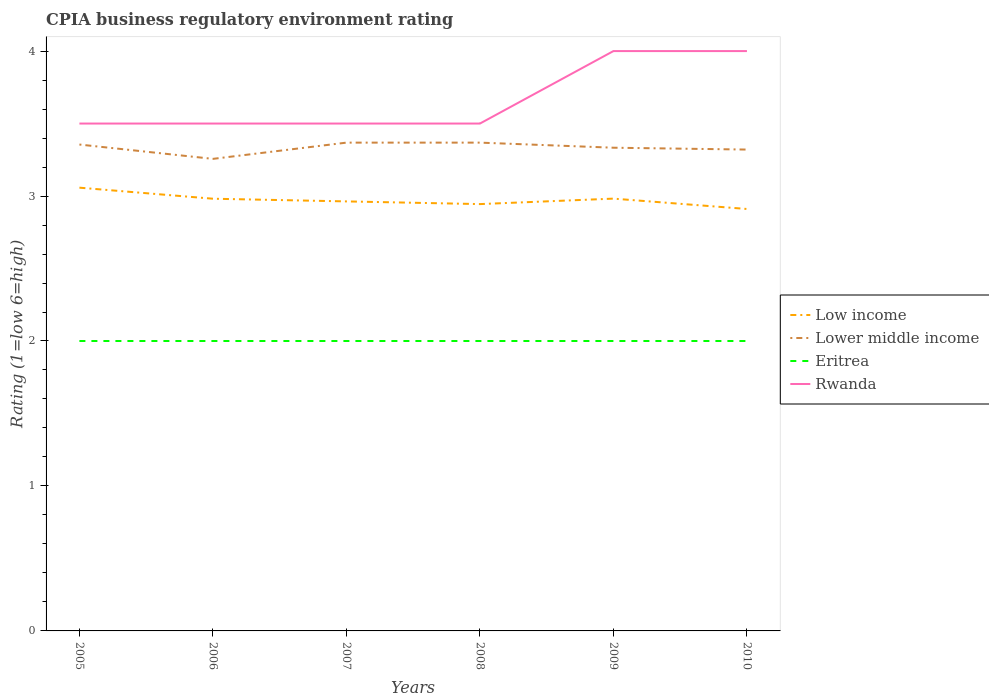How many different coloured lines are there?
Provide a short and direct response. 4. Is the number of lines equal to the number of legend labels?
Make the answer very short. Yes. Across all years, what is the maximum CPIA rating in Low income?
Keep it short and to the point. 2.91. What is the total CPIA rating in Lower middle income in the graph?
Your response must be concise. -0.01. What is the difference between the highest and the second highest CPIA rating in Rwanda?
Offer a terse response. 0.5. How many years are there in the graph?
Your answer should be very brief. 6. What is the difference between two consecutive major ticks on the Y-axis?
Your answer should be very brief. 1. Are the values on the major ticks of Y-axis written in scientific E-notation?
Your answer should be compact. No. Does the graph contain grids?
Provide a short and direct response. No. Where does the legend appear in the graph?
Make the answer very short. Center right. How many legend labels are there?
Offer a very short reply. 4. What is the title of the graph?
Your answer should be very brief. CPIA business regulatory environment rating. What is the label or title of the X-axis?
Your answer should be compact. Years. What is the label or title of the Y-axis?
Provide a succinct answer. Rating (1=low 6=high). What is the Rating (1=low 6=high) of Low income in 2005?
Offer a terse response. 3.06. What is the Rating (1=low 6=high) of Lower middle income in 2005?
Your answer should be compact. 3.36. What is the Rating (1=low 6=high) of Eritrea in 2005?
Give a very brief answer. 2. What is the Rating (1=low 6=high) in Rwanda in 2005?
Provide a succinct answer. 3.5. What is the Rating (1=low 6=high) of Low income in 2006?
Give a very brief answer. 2.98. What is the Rating (1=low 6=high) in Lower middle income in 2006?
Your response must be concise. 3.26. What is the Rating (1=low 6=high) of Eritrea in 2006?
Provide a succinct answer. 2. What is the Rating (1=low 6=high) of Rwanda in 2006?
Offer a very short reply. 3.5. What is the Rating (1=low 6=high) in Low income in 2007?
Offer a very short reply. 2.96. What is the Rating (1=low 6=high) of Lower middle income in 2007?
Keep it short and to the point. 3.37. What is the Rating (1=low 6=high) of Eritrea in 2007?
Provide a short and direct response. 2. What is the Rating (1=low 6=high) in Low income in 2008?
Your answer should be compact. 2.94. What is the Rating (1=low 6=high) in Lower middle income in 2008?
Your answer should be compact. 3.37. What is the Rating (1=low 6=high) of Low income in 2009?
Offer a terse response. 2.98. What is the Rating (1=low 6=high) in Lower middle income in 2009?
Give a very brief answer. 3.33. What is the Rating (1=low 6=high) of Rwanda in 2009?
Provide a succinct answer. 4. What is the Rating (1=low 6=high) of Low income in 2010?
Offer a very short reply. 2.91. What is the Rating (1=low 6=high) in Lower middle income in 2010?
Offer a very short reply. 3.32. Across all years, what is the maximum Rating (1=low 6=high) of Low income?
Your response must be concise. 3.06. Across all years, what is the maximum Rating (1=low 6=high) in Lower middle income?
Your answer should be very brief. 3.37. Across all years, what is the maximum Rating (1=low 6=high) in Eritrea?
Provide a succinct answer. 2. Across all years, what is the maximum Rating (1=low 6=high) of Rwanda?
Provide a short and direct response. 4. Across all years, what is the minimum Rating (1=low 6=high) in Low income?
Your response must be concise. 2.91. Across all years, what is the minimum Rating (1=low 6=high) in Lower middle income?
Provide a short and direct response. 3.26. Across all years, what is the minimum Rating (1=low 6=high) in Eritrea?
Ensure brevity in your answer.  2. What is the total Rating (1=low 6=high) in Low income in the graph?
Make the answer very short. 17.84. What is the total Rating (1=low 6=high) in Lower middle income in the graph?
Make the answer very short. 20. What is the total Rating (1=low 6=high) of Rwanda in the graph?
Give a very brief answer. 22. What is the difference between the Rating (1=low 6=high) of Low income in 2005 and that in 2006?
Offer a very short reply. 0.08. What is the difference between the Rating (1=low 6=high) of Lower middle income in 2005 and that in 2006?
Keep it short and to the point. 0.1. What is the difference between the Rating (1=low 6=high) of Eritrea in 2005 and that in 2006?
Ensure brevity in your answer.  0. What is the difference between the Rating (1=low 6=high) in Rwanda in 2005 and that in 2006?
Offer a terse response. 0. What is the difference between the Rating (1=low 6=high) in Low income in 2005 and that in 2007?
Offer a terse response. 0.09. What is the difference between the Rating (1=low 6=high) of Lower middle income in 2005 and that in 2007?
Keep it short and to the point. -0.01. What is the difference between the Rating (1=low 6=high) in Eritrea in 2005 and that in 2007?
Your answer should be compact. 0. What is the difference between the Rating (1=low 6=high) in Low income in 2005 and that in 2008?
Your response must be concise. 0.11. What is the difference between the Rating (1=low 6=high) of Lower middle income in 2005 and that in 2008?
Make the answer very short. -0.01. What is the difference between the Rating (1=low 6=high) in Rwanda in 2005 and that in 2008?
Ensure brevity in your answer.  0. What is the difference between the Rating (1=low 6=high) of Low income in 2005 and that in 2009?
Provide a succinct answer. 0.08. What is the difference between the Rating (1=low 6=high) of Lower middle income in 2005 and that in 2009?
Offer a terse response. 0.02. What is the difference between the Rating (1=low 6=high) in Eritrea in 2005 and that in 2009?
Offer a very short reply. 0. What is the difference between the Rating (1=low 6=high) of Rwanda in 2005 and that in 2009?
Offer a very short reply. -0.5. What is the difference between the Rating (1=low 6=high) in Low income in 2005 and that in 2010?
Give a very brief answer. 0.15. What is the difference between the Rating (1=low 6=high) of Lower middle income in 2005 and that in 2010?
Keep it short and to the point. 0.03. What is the difference between the Rating (1=low 6=high) in Eritrea in 2005 and that in 2010?
Your answer should be compact. 0. What is the difference between the Rating (1=low 6=high) of Rwanda in 2005 and that in 2010?
Offer a terse response. -0.5. What is the difference between the Rating (1=low 6=high) in Low income in 2006 and that in 2007?
Provide a short and direct response. 0.02. What is the difference between the Rating (1=low 6=high) in Lower middle income in 2006 and that in 2007?
Ensure brevity in your answer.  -0.11. What is the difference between the Rating (1=low 6=high) of Eritrea in 2006 and that in 2007?
Provide a short and direct response. 0. What is the difference between the Rating (1=low 6=high) in Rwanda in 2006 and that in 2007?
Provide a short and direct response. 0. What is the difference between the Rating (1=low 6=high) of Low income in 2006 and that in 2008?
Ensure brevity in your answer.  0.04. What is the difference between the Rating (1=low 6=high) in Lower middle income in 2006 and that in 2008?
Your answer should be compact. -0.11. What is the difference between the Rating (1=low 6=high) in Eritrea in 2006 and that in 2008?
Make the answer very short. 0. What is the difference between the Rating (1=low 6=high) in Low income in 2006 and that in 2009?
Offer a very short reply. -0. What is the difference between the Rating (1=low 6=high) in Lower middle income in 2006 and that in 2009?
Keep it short and to the point. -0.08. What is the difference between the Rating (1=low 6=high) of Low income in 2006 and that in 2010?
Ensure brevity in your answer.  0.07. What is the difference between the Rating (1=low 6=high) of Lower middle income in 2006 and that in 2010?
Keep it short and to the point. -0.06. What is the difference between the Rating (1=low 6=high) of Eritrea in 2006 and that in 2010?
Offer a terse response. 0. What is the difference between the Rating (1=low 6=high) in Low income in 2007 and that in 2008?
Offer a very short reply. 0.02. What is the difference between the Rating (1=low 6=high) of Lower middle income in 2007 and that in 2008?
Keep it short and to the point. 0. What is the difference between the Rating (1=low 6=high) of Rwanda in 2007 and that in 2008?
Offer a very short reply. 0. What is the difference between the Rating (1=low 6=high) in Low income in 2007 and that in 2009?
Offer a terse response. -0.02. What is the difference between the Rating (1=low 6=high) of Lower middle income in 2007 and that in 2009?
Your answer should be very brief. 0.04. What is the difference between the Rating (1=low 6=high) in Low income in 2007 and that in 2010?
Provide a short and direct response. 0.05. What is the difference between the Rating (1=low 6=high) in Lower middle income in 2007 and that in 2010?
Your response must be concise. 0.05. What is the difference between the Rating (1=low 6=high) of Rwanda in 2007 and that in 2010?
Your answer should be very brief. -0.5. What is the difference between the Rating (1=low 6=high) in Low income in 2008 and that in 2009?
Ensure brevity in your answer.  -0.04. What is the difference between the Rating (1=low 6=high) of Lower middle income in 2008 and that in 2009?
Ensure brevity in your answer.  0.04. What is the difference between the Rating (1=low 6=high) of Low income in 2008 and that in 2010?
Your response must be concise. 0.03. What is the difference between the Rating (1=low 6=high) of Lower middle income in 2008 and that in 2010?
Offer a very short reply. 0.05. What is the difference between the Rating (1=low 6=high) in Eritrea in 2008 and that in 2010?
Your answer should be very brief. 0. What is the difference between the Rating (1=low 6=high) of Low income in 2009 and that in 2010?
Provide a succinct answer. 0.07. What is the difference between the Rating (1=low 6=high) of Lower middle income in 2009 and that in 2010?
Provide a succinct answer. 0.01. What is the difference between the Rating (1=low 6=high) in Eritrea in 2009 and that in 2010?
Provide a succinct answer. 0. What is the difference between the Rating (1=low 6=high) of Low income in 2005 and the Rating (1=low 6=high) of Lower middle income in 2006?
Offer a very short reply. -0.2. What is the difference between the Rating (1=low 6=high) in Low income in 2005 and the Rating (1=low 6=high) in Eritrea in 2006?
Give a very brief answer. 1.06. What is the difference between the Rating (1=low 6=high) of Low income in 2005 and the Rating (1=low 6=high) of Rwanda in 2006?
Offer a very short reply. -0.44. What is the difference between the Rating (1=low 6=high) of Lower middle income in 2005 and the Rating (1=low 6=high) of Eritrea in 2006?
Offer a terse response. 1.36. What is the difference between the Rating (1=low 6=high) in Lower middle income in 2005 and the Rating (1=low 6=high) in Rwanda in 2006?
Your answer should be compact. -0.14. What is the difference between the Rating (1=low 6=high) of Eritrea in 2005 and the Rating (1=low 6=high) of Rwanda in 2006?
Your answer should be very brief. -1.5. What is the difference between the Rating (1=low 6=high) in Low income in 2005 and the Rating (1=low 6=high) in Lower middle income in 2007?
Offer a terse response. -0.31. What is the difference between the Rating (1=low 6=high) in Low income in 2005 and the Rating (1=low 6=high) in Eritrea in 2007?
Your response must be concise. 1.06. What is the difference between the Rating (1=low 6=high) in Low income in 2005 and the Rating (1=low 6=high) in Rwanda in 2007?
Offer a very short reply. -0.44. What is the difference between the Rating (1=low 6=high) of Lower middle income in 2005 and the Rating (1=low 6=high) of Eritrea in 2007?
Your answer should be very brief. 1.36. What is the difference between the Rating (1=low 6=high) in Lower middle income in 2005 and the Rating (1=low 6=high) in Rwanda in 2007?
Your response must be concise. -0.14. What is the difference between the Rating (1=low 6=high) in Eritrea in 2005 and the Rating (1=low 6=high) in Rwanda in 2007?
Your response must be concise. -1.5. What is the difference between the Rating (1=low 6=high) of Low income in 2005 and the Rating (1=low 6=high) of Lower middle income in 2008?
Your answer should be very brief. -0.31. What is the difference between the Rating (1=low 6=high) of Low income in 2005 and the Rating (1=low 6=high) of Eritrea in 2008?
Provide a short and direct response. 1.06. What is the difference between the Rating (1=low 6=high) of Low income in 2005 and the Rating (1=low 6=high) of Rwanda in 2008?
Offer a terse response. -0.44. What is the difference between the Rating (1=low 6=high) in Lower middle income in 2005 and the Rating (1=low 6=high) in Eritrea in 2008?
Offer a very short reply. 1.36. What is the difference between the Rating (1=low 6=high) of Lower middle income in 2005 and the Rating (1=low 6=high) of Rwanda in 2008?
Provide a short and direct response. -0.14. What is the difference between the Rating (1=low 6=high) of Eritrea in 2005 and the Rating (1=low 6=high) of Rwanda in 2008?
Offer a terse response. -1.5. What is the difference between the Rating (1=low 6=high) of Low income in 2005 and the Rating (1=low 6=high) of Lower middle income in 2009?
Provide a short and direct response. -0.28. What is the difference between the Rating (1=low 6=high) in Low income in 2005 and the Rating (1=low 6=high) in Eritrea in 2009?
Offer a terse response. 1.06. What is the difference between the Rating (1=low 6=high) of Low income in 2005 and the Rating (1=low 6=high) of Rwanda in 2009?
Provide a short and direct response. -0.94. What is the difference between the Rating (1=low 6=high) in Lower middle income in 2005 and the Rating (1=low 6=high) in Eritrea in 2009?
Your answer should be compact. 1.36. What is the difference between the Rating (1=low 6=high) of Lower middle income in 2005 and the Rating (1=low 6=high) of Rwanda in 2009?
Your answer should be very brief. -0.64. What is the difference between the Rating (1=low 6=high) in Eritrea in 2005 and the Rating (1=low 6=high) in Rwanda in 2009?
Make the answer very short. -2. What is the difference between the Rating (1=low 6=high) in Low income in 2005 and the Rating (1=low 6=high) in Lower middle income in 2010?
Make the answer very short. -0.26. What is the difference between the Rating (1=low 6=high) in Low income in 2005 and the Rating (1=low 6=high) in Eritrea in 2010?
Give a very brief answer. 1.06. What is the difference between the Rating (1=low 6=high) in Low income in 2005 and the Rating (1=low 6=high) in Rwanda in 2010?
Your response must be concise. -0.94. What is the difference between the Rating (1=low 6=high) of Lower middle income in 2005 and the Rating (1=low 6=high) of Eritrea in 2010?
Offer a very short reply. 1.36. What is the difference between the Rating (1=low 6=high) of Lower middle income in 2005 and the Rating (1=low 6=high) of Rwanda in 2010?
Give a very brief answer. -0.64. What is the difference between the Rating (1=low 6=high) in Low income in 2006 and the Rating (1=low 6=high) in Lower middle income in 2007?
Keep it short and to the point. -0.39. What is the difference between the Rating (1=low 6=high) in Low income in 2006 and the Rating (1=low 6=high) in Eritrea in 2007?
Offer a very short reply. 0.98. What is the difference between the Rating (1=low 6=high) of Low income in 2006 and the Rating (1=low 6=high) of Rwanda in 2007?
Keep it short and to the point. -0.52. What is the difference between the Rating (1=low 6=high) of Lower middle income in 2006 and the Rating (1=low 6=high) of Eritrea in 2007?
Keep it short and to the point. 1.26. What is the difference between the Rating (1=low 6=high) of Lower middle income in 2006 and the Rating (1=low 6=high) of Rwanda in 2007?
Provide a succinct answer. -0.24. What is the difference between the Rating (1=low 6=high) of Eritrea in 2006 and the Rating (1=low 6=high) of Rwanda in 2007?
Your answer should be very brief. -1.5. What is the difference between the Rating (1=low 6=high) of Low income in 2006 and the Rating (1=low 6=high) of Lower middle income in 2008?
Your answer should be very brief. -0.39. What is the difference between the Rating (1=low 6=high) of Low income in 2006 and the Rating (1=low 6=high) of Eritrea in 2008?
Provide a short and direct response. 0.98. What is the difference between the Rating (1=low 6=high) of Low income in 2006 and the Rating (1=low 6=high) of Rwanda in 2008?
Offer a terse response. -0.52. What is the difference between the Rating (1=low 6=high) of Lower middle income in 2006 and the Rating (1=low 6=high) of Eritrea in 2008?
Keep it short and to the point. 1.26. What is the difference between the Rating (1=low 6=high) in Lower middle income in 2006 and the Rating (1=low 6=high) in Rwanda in 2008?
Your answer should be compact. -0.24. What is the difference between the Rating (1=low 6=high) of Eritrea in 2006 and the Rating (1=low 6=high) of Rwanda in 2008?
Offer a terse response. -1.5. What is the difference between the Rating (1=low 6=high) of Low income in 2006 and the Rating (1=low 6=high) of Lower middle income in 2009?
Ensure brevity in your answer.  -0.35. What is the difference between the Rating (1=low 6=high) of Low income in 2006 and the Rating (1=low 6=high) of Eritrea in 2009?
Provide a succinct answer. 0.98. What is the difference between the Rating (1=low 6=high) in Low income in 2006 and the Rating (1=low 6=high) in Rwanda in 2009?
Offer a very short reply. -1.02. What is the difference between the Rating (1=low 6=high) in Lower middle income in 2006 and the Rating (1=low 6=high) in Eritrea in 2009?
Provide a short and direct response. 1.26. What is the difference between the Rating (1=low 6=high) in Lower middle income in 2006 and the Rating (1=low 6=high) in Rwanda in 2009?
Offer a very short reply. -0.74. What is the difference between the Rating (1=low 6=high) in Eritrea in 2006 and the Rating (1=low 6=high) in Rwanda in 2009?
Keep it short and to the point. -2. What is the difference between the Rating (1=low 6=high) in Low income in 2006 and the Rating (1=low 6=high) in Lower middle income in 2010?
Give a very brief answer. -0.34. What is the difference between the Rating (1=low 6=high) in Low income in 2006 and the Rating (1=low 6=high) in Eritrea in 2010?
Provide a short and direct response. 0.98. What is the difference between the Rating (1=low 6=high) of Low income in 2006 and the Rating (1=low 6=high) of Rwanda in 2010?
Provide a short and direct response. -1.02. What is the difference between the Rating (1=low 6=high) in Lower middle income in 2006 and the Rating (1=low 6=high) in Eritrea in 2010?
Your response must be concise. 1.26. What is the difference between the Rating (1=low 6=high) in Lower middle income in 2006 and the Rating (1=low 6=high) in Rwanda in 2010?
Your response must be concise. -0.74. What is the difference between the Rating (1=low 6=high) in Eritrea in 2006 and the Rating (1=low 6=high) in Rwanda in 2010?
Make the answer very short. -2. What is the difference between the Rating (1=low 6=high) in Low income in 2007 and the Rating (1=low 6=high) in Lower middle income in 2008?
Provide a succinct answer. -0.41. What is the difference between the Rating (1=low 6=high) in Low income in 2007 and the Rating (1=low 6=high) in Rwanda in 2008?
Make the answer very short. -0.54. What is the difference between the Rating (1=low 6=high) in Lower middle income in 2007 and the Rating (1=low 6=high) in Eritrea in 2008?
Offer a very short reply. 1.37. What is the difference between the Rating (1=low 6=high) of Lower middle income in 2007 and the Rating (1=low 6=high) of Rwanda in 2008?
Your response must be concise. -0.13. What is the difference between the Rating (1=low 6=high) in Low income in 2007 and the Rating (1=low 6=high) in Lower middle income in 2009?
Keep it short and to the point. -0.37. What is the difference between the Rating (1=low 6=high) in Low income in 2007 and the Rating (1=low 6=high) in Rwanda in 2009?
Offer a terse response. -1.04. What is the difference between the Rating (1=low 6=high) in Lower middle income in 2007 and the Rating (1=low 6=high) in Eritrea in 2009?
Give a very brief answer. 1.37. What is the difference between the Rating (1=low 6=high) in Lower middle income in 2007 and the Rating (1=low 6=high) in Rwanda in 2009?
Give a very brief answer. -0.63. What is the difference between the Rating (1=low 6=high) in Low income in 2007 and the Rating (1=low 6=high) in Lower middle income in 2010?
Your answer should be compact. -0.36. What is the difference between the Rating (1=low 6=high) in Low income in 2007 and the Rating (1=low 6=high) in Eritrea in 2010?
Provide a succinct answer. 0.96. What is the difference between the Rating (1=low 6=high) in Low income in 2007 and the Rating (1=low 6=high) in Rwanda in 2010?
Your answer should be compact. -1.04. What is the difference between the Rating (1=low 6=high) of Lower middle income in 2007 and the Rating (1=low 6=high) of Eritrea in 2010?
Make the answer very short. 1.37. What is the difference between the Rating (1=low 6=high) in Lower middle income in 2007 and the Rating (1=low 6=high) in Rwanda in 2010?
Provide a succinct answer. -0.63. What is the difference between the Rating (1=low 6=high) in Eritrea in 2007 and the Rating (1=low 6=high) in Rwanda in 2010?
Your answer should be very brief. -2. What is the difference between the Rating (1=low 6=high) in Low income in 2008 and the Rating (1=low 6=high) in Lower middle income in 2009?
Your answer should be very brief. -0.39. What is the difference between the Rating (1=low 6=high) in Low income in 2008 and the Rating (1=low 6=high) in Rwanda in 2009?
Your response must be concise. -1.06. What is the difference between the Rating (1=low 6=high) of Lower middle income in 2008 and the Rating (1=low 6=high) of Eritrea in 2009?
Offer a terse response. 1.37. What is the difference between the Rating (1=low 6=high) of Lower middle income in 2008 and the Rating (1=low 6=high) of Rwanda in 2009?
Provide a succinct answer. -0.63. What is the difference between the Rating (1=low 6=high) of Eritrea in 2008 and the Rating (1=low 6=high) of Rwanda in 2009?
Offer a very short reply. -2. What is the difference between the Rating (1=low 6=high) in Low income in 2008 and the Rating (1=low 6=high) in Lower middle income in 2010?
Give a very brief answer. -0.38. What is the difference between the Rating (1=low 6=high) in Low income in 2008 and the Rating (1=low 6=high) in Rwanda in 2010?
Ensure brevity in your answer.  -1.06. What is the difference between the Rating (1=low 6=high) in Lower middle income in 2008 and the Rating (1=low 6=high) in Eritrea in 2010?
Your answer should be compact. 1.37. What is the difference between the Rating (1=low 6=high) of Lower middle income in 2008 and the Rating (1=low 6=high) of Rwanda in 2010?
Provide a short and direct response. -0.63. What is the difference between the Rating (1=low 6=high) in Eritrea in 2008 and the Rating (1=low 6=high) in Rwanda in 2010?
Offer a terse response. -2. What is the difference between the Rating (1=low 6=high) in Low income in 2009 and the Rating (1=low 6=high) in Lower middle income in 2010?
Your answer should be very brief. -0.34. What is the difference between the Rating (1=low 6=high) in Low income in 2009 and the Rating (1=low 6=high) in Eritrea in 2010?
Provide a short and direct response. 0.98. What is the difference between the Rating (1=low 6=high) in Low income in 2009 and the Rating (1=low 6=high) in Rwanda in 2010?
Give a very brief answer. -1.02. What is the average Rating (1=low 6=high) of Low income per year?
Your answer should be very brief. 2.97. What is the average Rating (1=low 6=high) in Lower middle income per year?
Make the answer very short. 3.33. What is the average Rating (1=low 6=high) in Eritrea per year?
Offer a terse response. 2. What is the average Rating (1=low 6=high) of Rwanda per year?
Provide a succinct answer. 3.67. In the year 2005, what is the difference between the Rating (1=low 6=high) of Low income and Rating (1=low 6=high) of Lower middle income?
Your response must be concise. -0.3. In the year 2005, what is the difference between the Rating (1=low 6=high) in Low income and Rating (1=low 6=high) in Eritrea?
Offer a very short reply. 1.06. In the year 2005, what is the difference between the Rating (1=low 6=high) in Low income and Rating (1=low 6=high) in Rwanda?
Provide a succinct answer. -0.44. In the year 2005, what is the difference between the Rating (1=low 6=high) in Lower middle income and Rating (1=low 6=high) in Eritrea?
Provide a succinct answer. 1.36. In the year 2005, what is the difference between the Rating (1=low 6=high) in Lower middle income and Rating (1=low 6=high) in Rwanda?
Your answer should be compact. -0.14. In the year 2005, what is the difference between the Rating (1=low 6=high) in Eritrea and Rating (1=low 6=high) in Rwanda?
Your response must be concise. -1.5. In the year 2006, what is the difference between the Rating (1=low 6=high) of Low income and Rating (1=low 6=high) of Lower middle income?
Offer a very short reply. -0.27. In the year 2006, what is the difference between the Rating (1=low 6=high) of Low income and Rating (1=low 6=high) of Eritrea?
Make the answer very short. 0.98. In the year 2006, what is the difference between the Rating (1=low 6=high) in Low income and Rating (1=low 6=high) in Rwanda?
Give a very brief answer. -0.52. In the year 2006, what is the difference between the Rating (1=low 6=high) of Lower middle income and Rating (1=low 6=high) of Eritrea?
Ensure brevity in your answer.  1.26. In the year 2006, what is the difference between the Rating (1=low 6=high) of Lower middle income and Rating (1=low 6=high) of Rwanda?
Offer a terse response. -0.24. In the year 2006, what is the difference between the Rating (1=low 6=high) of Eritrea and Rating (1=low 6=high) of Rwanda?
Your answer should be compact. -1.5. In the year 2007, what is the difference between the Rating (1=low 6=high) of Low income and Rating (1=low 6=high) of Lower middle income?
Offer a very short reply. -0.41. In the year 2007, what is the difference between the Rating (1=low 6=high) of Low income and Rating (1=low 6=high) of Rwanda?
Make the answer very short. -0.54. In the year 2007, what is the difference between the Rating (1=low 6=high) in Lower middle income and Rating (1=low 6=high) in Eritrea?
Offer a very short reply. 1.37. In the year 2007, what is the difference between the Rating (1=low 6=high) of Lower middle income and Rating (1=low 6=high) of Rwanda?
Offer a very short reply. -0.13. In the year 2007, what is the difference between the Rating (1=low 6=high) in Eritrea and Rating (1=low 6=high) in Rwanda?
Offer a very short reply. -1.5. In the year 2008, what is the difference between the Rating (1=low 6=high) of Low income and Rating (1=low 6=high) of Lower middle income?
Ensure brevity in your answer.  -0.42. In the year 2008, what is the difference between the Rating (1=low 6=high) of Low income and Rating (1=low 6=high) of Rwanda?
Your answer should be compact. -0.56. In the year 2008, what is the difference between the Rating (1=low 6=high) of Lower middle income and Rating (1=low 6=high) of Eritrea?
Your response must be concise. 1.37. In the year 2008, what is the difference between the Rating (1=low 6=high) in Lower middle income and Rating (1=low 6=high) in Rwanda?
Make the answer very short. -0.13. In the year 2009, what is the difference between the Rating (1=low 6=high) in Low income and Rating (1=low 6=high) in Lower middle income?
Provide a succinct answer. -0.35. In the year 2009, what is the difference between the Rating (1=low 6=high) in Low income and Rating (1=low 6=high) in Eritrea?
Give a very brief answer. 0.98. In the year 2009, what is the difference between the Rating (1=low 6=high) in Low income and Rating (1=low 6=high) in Rwanda?
Your response must be concise. -1.02. In the year 2009, what is the difference between the Rating (1=low 6=high) in Lower middle income and Rating (1=low 6=high) in Rwanda?
Offer a very short reply. -0.67. In the year 2010, what is the difference between the Rating (1=low 6=high) of Low income and Rating (1=low 6=high) of Lower middle income?
Make the answer very short. -0.41. In the year 2010, what is the difference between the Rating (1=low 6=high) in Low income and Rating (1=low 6=high) in Eritrea?
Make the answer very short. 0.91. In the year 2010, what is the difference between the Rating (1=low 6=high) of Low income and Rating (1=low 6=high) of Rwanda?
Give a very brief answer. -1.09. In the year 2010, what is the difference between the Rating (1=low 6=high) in Lower middle income and Rating (1=low 6=high) in Eritrea?
Your answer should be compact. 1.32. In the year 2010, what is the difference between the Rating (1=low 6=high) of Lower middle income and Rating (1=low 6=high) of Rwanda?
Offer a terse response. -0.68. In the year 2010, what is the difference between the Rating (1=low 6=high) of Eritrea and Rating (1=low 6=high) of Rwanda?
Ensure brevity in your answer.  -2. What is the ratio of the Rating (1=low 6=high) in Low income in 2005 to that in 2006?
Offer a terse response. 1.03. What is the ratio of the Rating (1=low 6=high) in Lower middle income in 2005 to that in 2006?
Ensure brevity in your answer.  1.03. What is the ratio of the Rating (1=low 6=high) of Rwanda in 2005 to that in 2006?
Provide a succinct answer. 1. What is the ratio of the Rating (1=low 6=high) of Low income in 2005 to that in 2007?
Provide a short and direct response. 1.03. What is the ratio of the Rating (1=low 6=high) in Rwanda in 2005 to that in 2007?
Give a very brief answer. 1. What is the ratio of the Rating (1=low 6=high) in Eritrea in 2005 to that in 2008?
Your answer should be very brief. 1. What is the ratio of the Rating (1=low 6=high) of Low income in 2005 to that in 2009?
Your answer should be compact. 1.03. What is the ratio of the Rating (1=low 6=high) of Lower middle income in 2005 to that in 2009?
Provide a short and direct response. 1.01. What is the ratio of the Rating (1=low 6=high) in Eritrea in 2005 to that in 2009?
Offer a terse response. 1. What is the ratio of the Rating (1=low 6=high) of Low income in 2005 to that in 2010?
Ensure brevity in your answer.  1.05. What is the ratio of the Rating (1=low 6=high) in Lower middle income in 2005 to that in 2010?
Offer a terse response. 1.01. What is the ratio of the Rating (1=low 6=high) of Lower middle income in 2006 to that in 2007?
Provide a short and direct response. 0.97. What is the ratio of the Rating (1=low 6=high) of Eritrea in 2006 to that in 2007?
Keep it short and to the point. 1. What is the ratio of the Rating (1=low 6=high) of Rwanda in 2006 to that in 2007?
Your answer should be very brief. 1. What is the ratio of the Rating (1=low 6=high) in Low income in 2006 to that in 2008?
Keep it short and to the point. 1.01. What is the ratio of the Rating (1=low 6=high) of Lower middle income in 2006 to that in 2008?
Your answer should be compact. 0.97. What is the ratio of the Rating (1=low 6=high) in Eritrea in 2006 to that in 2008?
Make the answer very short. 1. What is the ratio of the Rating (1=low 6=high) in Rwanda in 2006 to that in 2008?
Offer a very short reply. 1. What is the ratio of the Rating (1=low 6=high) of Lower middle income in 2006 to that in 2009?
Offer a very short reply. 0.98. What is the ratio of the Rating (1=low 6=high) in Eritrea in 2006 to that in 2009?
Offer a very short reply. 1. What is the ratio of the Rating (1=low 6=high) in Low income in 2006 to that in 2010?
Your response must be concise. 1.02. What is the ratio of the Rating (1=low 6=high) in Lower middle income in 2006 to that in 2010?
Ensure brevity in your answer.  0.98. What is the ratio of the Rating (1=low 6=high) of Eritrea in 2006 to that in 2010?
Your answer should be very brief. 1. What is the ratio of the Rating (1=low 6=high) in Rwanda in 2006 to that in 2010?
Keep it short and to the point. 0.88. What is the ratio of the Rating (1=low 6=high) of Low income in 2007 to that in 2009?
Offer a very short reply. 0.99. What is the ratio of the Rating (1=low 6=high) of Lower middle income in 2007 to that in 2009?
Give a very brief answer. 1.01. What is the ratio of the Rating (1=low 6=high) in Eritrea in 2007 to that in 2009?
Your response must be concise. 1. What is the ratio of the Rating (1=low 6=high) in Low income in 2007 to that in 2010?
Offer a terse response. 1.02. What is the ratio of the Rating (1=low 6=high) of Lower middle income in 2007 to that in 2010?
Provide a short and direct response. 1.01. What is the ratio of the Rating (1=low 6=high) in Eritrea in 2007 to that in 2010?
Ensure brevity in your answer.  1. What is the ratio of the Rating (1=low 6=high) of Low income in 2008 to that in 2009?
Make the answer very short. 0.99. What is the ratio of the Rating (1=low 6=high) of Lower middle income in 2008 to that in 2009?
Provide a short and direct response. 1.01. What is the ratio of the Rating (1=low 6=high) in Eritrea in 2008 to that in 2009?
Your answer should be very brief. 1. What is the ratio of the Rating (1=low 6=high) in Low income in 2008 to that in 2010?
Offer a terse response. 1.01. What is the ratio of the Rating (1=low 6=high) in Lower middle income in 2008 to that in 2010?
Your answer should be compact. 1.01. What is the ratio of the Rating (1=low 6=high) of Low income in 2009 to that in 2010?
Give a very brief answer. 1.02. What is the ratio of the Rating (1=low 6=high) in Rwanda in 2009 to that in 2010?
Make the answer very short. 1. What is the difference between the highest and the second highest Rating (1=low 6=high) of Low income?
Make the answer very short. 0.08. What is the difference between the highest and the second highest Rating (1=low 6=high) of Lower middle income?
Offer a terse response. 0. What is the difference between the highest and the second highest Rating (1=low 6=high) in Rwanda?
Make the answer very short. 0. What is the difference between the highest and the lowest Rating (1=low 6=high) of Low income?
Your answer should be very brief. 0.15. What is the difference between the highest and the lowest Rating (1=low 6=high) of Lower middle income?
Make the answer very short. 0.11. What is the difference between the highest and the lowest Rating (1=low 6=high) in Eritrea?
Keep it short and to the point. 0. What is the difference between the highest and the lowest Rating (1=low 6=high) of Rwanda?
Give a very brief answer. 0.5. 